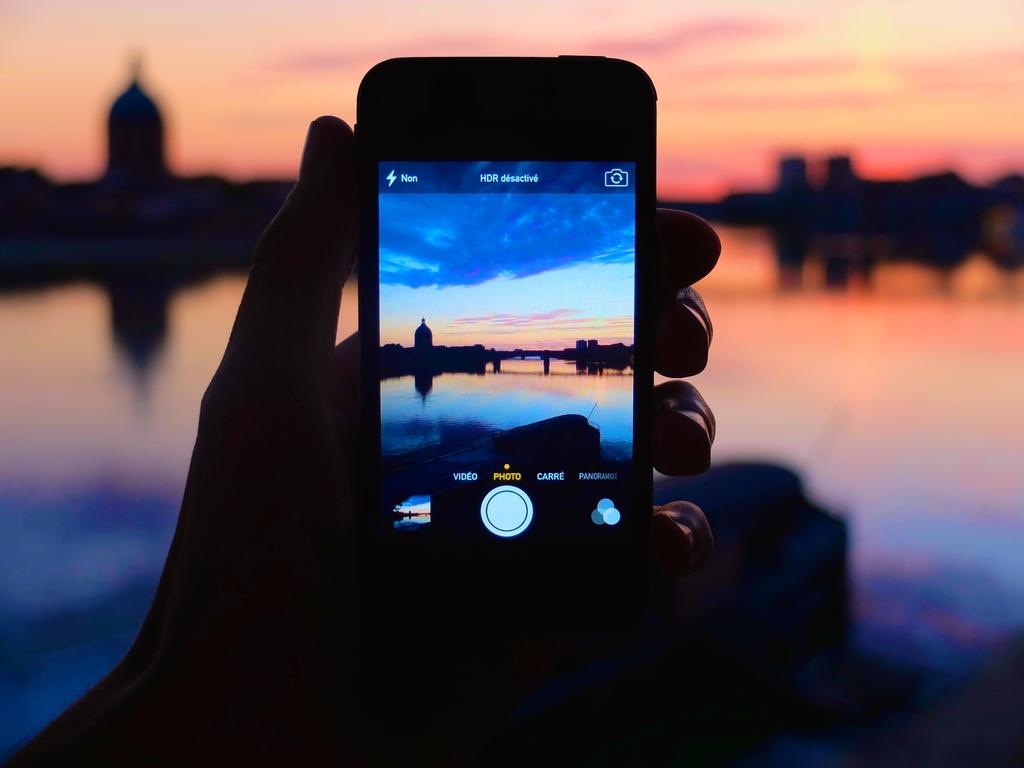What is displayed in the top center?
Provide a succinct answer. Hdr. 